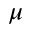Convert formula to latex. <formula><loc_0><loc_0><loc_500><loc_500>\mu</formula> 